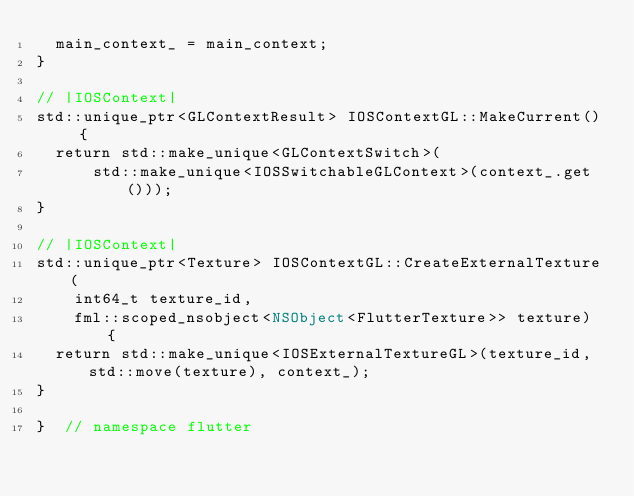Convert code to text. <code><loc_0><loc_0><loc_500><loc_500><_ObjectiveC_>  main_context_ = main_context;
}

// |IOSContext|
std::unique_ptr<GLContextResult> IOSContextGL::MakeCurrent() {
  return std::make_unique<GLContextSwitch>(
      std::make_unique<IOSSwitchableGLContext>(context_.get()));
}

// |IOSContext|
std::unique_ptr<Texture> IOSContextGL::CreateExternalTexture(
    int64_t texture_id,
    fml::scoped_nsobject<NSObject<FlutterTexture>> texture) {
  return std::make_unique<IOSExternalTextureGL>(texture_id, std::move(texture), context_);
}

}  // namespace flutter
</code> 